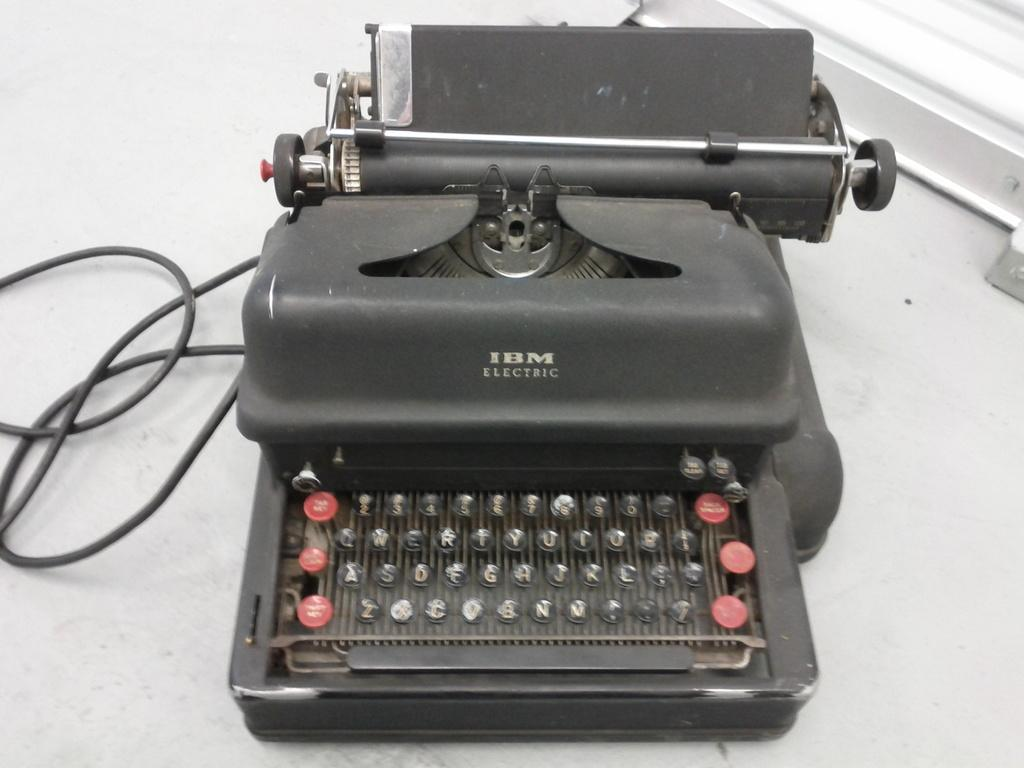What is the main object in the foreground of the image? There is a typewriter machine in the foreground of the image. What can be seen at the bottom of the image? There is a floor visible at the bottom of the image. How many caps are being worn by the cats on vacation in the image? There are no cats or vacations mentioned in the image, and therefore no caps can be observed. 